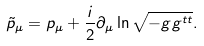<formula> <loc_0><loc_0><loc_500><loc_500>\tilde { p } _ { \mu } = p _ { \mu } + \frac { i } { 2 } \partial _ { \mu } \ln \sqrt { - g g ^ { t t } } .</formula> 